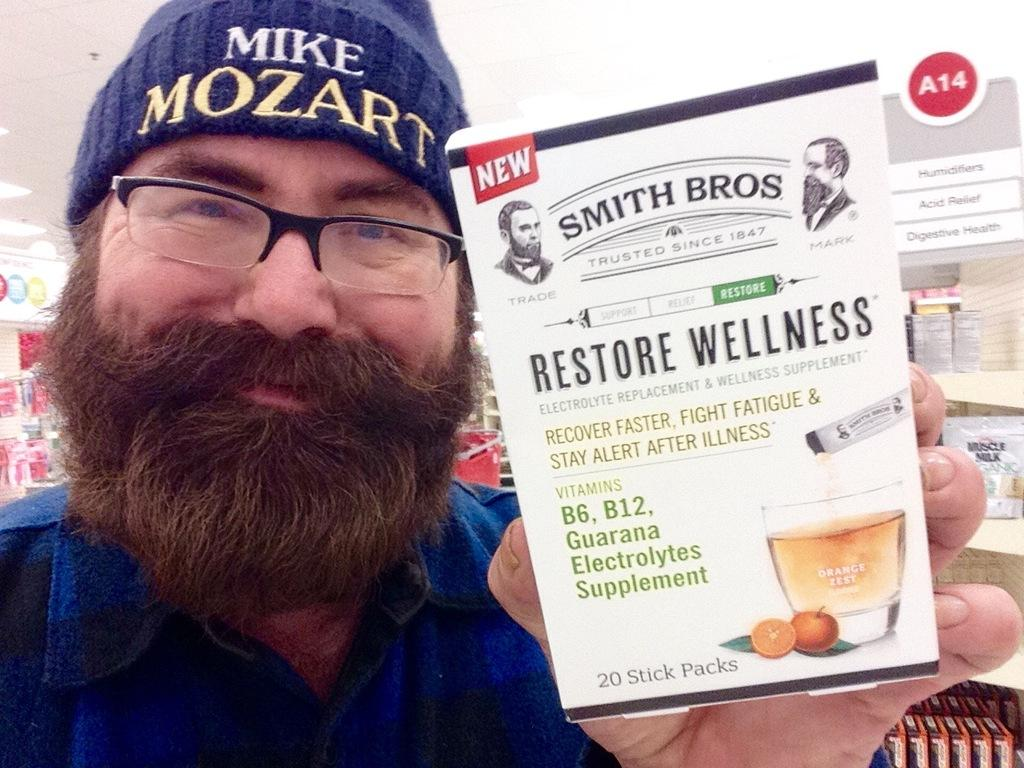What can be seen in the image? There is a person in the image. Can you describe the person's appearance? The person is wearing spectacles. What is the person holding in the image? The person is holding an object. What can be observed about the object being held? There is text written on the object. What type of boat is the fireman using to deliver the parcel in the image? There is no boat or fireman present in the image, and no parcel is being delivered. 